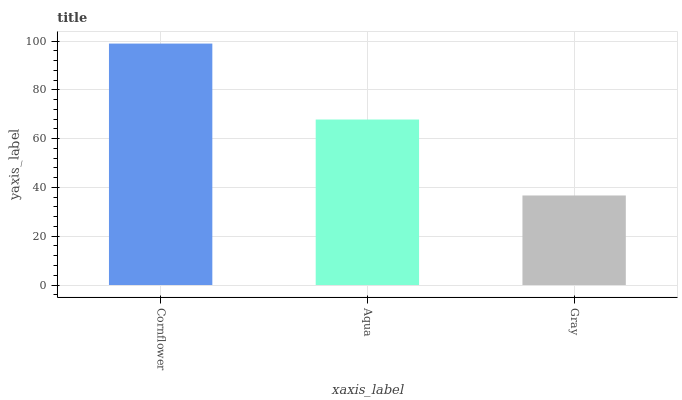Is Gray the minimum?
Answer yes or no. Yes. Is Cornflower the maximum?
Answer yes or no. Yes. Is Aqua the minimum?
Answer yes or no. No. Is Aqua the maximum?
Answer yes or no. No. Is Cornflower greater than Aqua?
Answer yes or no. Yes. Is Aqua less than Cornflower?
Answer yes or no. Yes. Is Aqua greater than Cornflower?
Answer yes or no. No. Is Cornflower less than Aqua?
Answer yes or no. No. Is Aqua the high median?
Answer yes or no. Yes. Is Aqua the low median?
Answer yes or no. Yes. Is Cornflower the high median?
Answer yes or no. No. Is Cornflower the low median?
Answer yes or no. No. 